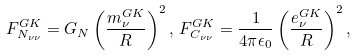<formula> <loc_0><loc_0><loc_500><loc_500>F ^ { G K } _ { N _ { \nu \nu } } = G _ { N } \left ( \frac { m _ { \nu } ^ { G K } } { R } \right ) ^ { 2 } , \, F ^ { G K } _ { C _ { \nu \nu } } = \frac { 1 } { 4 \pi \epsilon _ { 0 } } \left ( \frac { e _ { \nu } ^ { G K } } { R } \right ) ^ { 2 } ,</formula> 